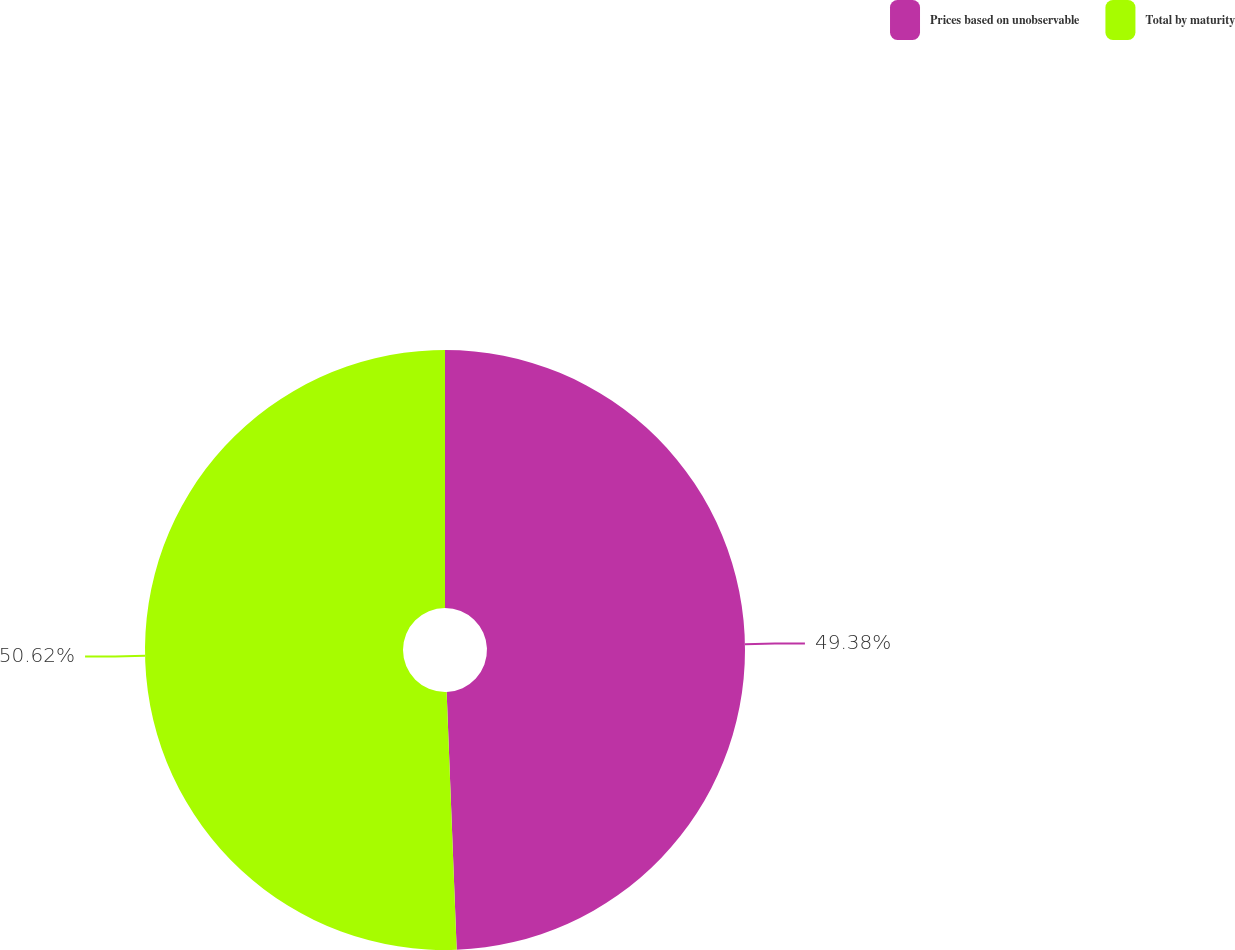Convert chart to OTSL. <chart><loc_0><loc_0><loc_500><loc_500><pie_chart><fcel>Prices based on unobservable<fcel>Total by maturity<nl><fcel>49.38%<fcel>50.62%<nl></chart> 